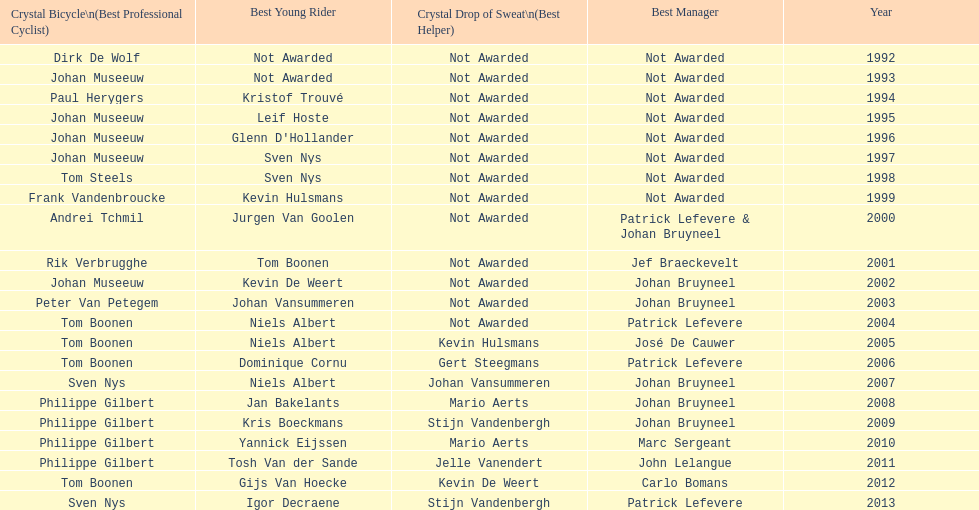Who has received the most best young rider honors? Niels Albert. 